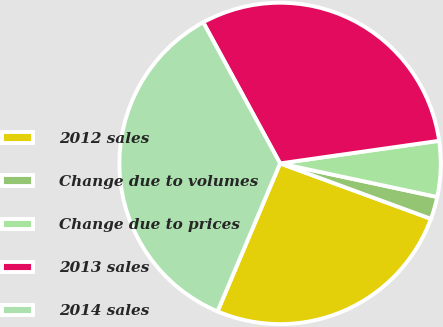<chart> <loc_0><loc_0><loc_500><loc_500><pie_chart><fcel>2012 sales<fcel>Change due to volumes<fcel>Change due to prices<fcel>2013 sales<fcel>2014 sales<nl><fcel>25.76%<fcel>2.25%<fcel>5.6%<fcel>30.69%<fcel>35.69%<nl></chart> 